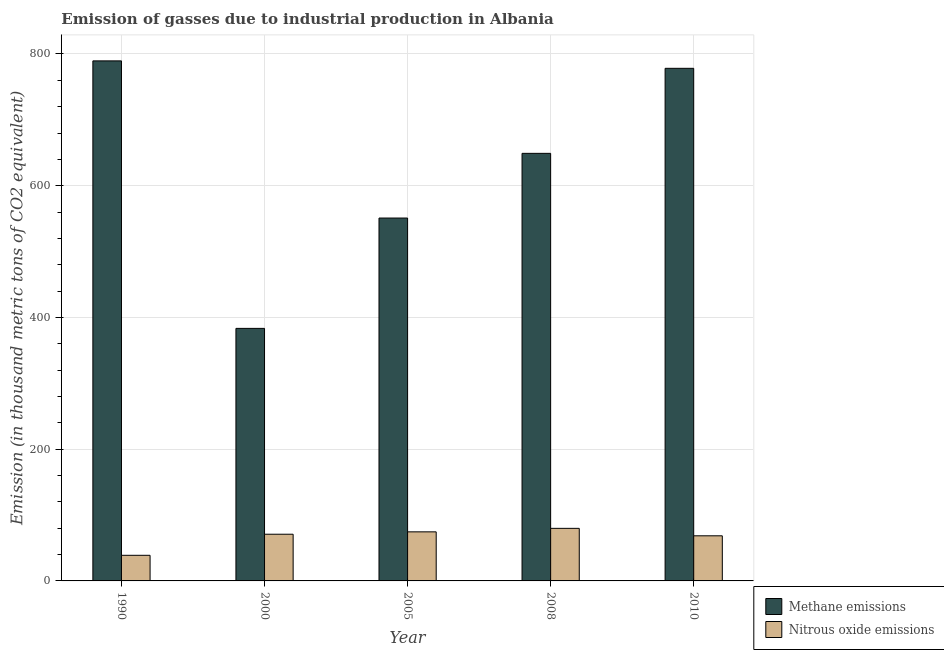Are the number of bars per tick equal to the number of legend labels?
Your response must be concise. Yes. In how many cases, is the number of bars for a given year not equal to the number of legend labels?
Offer a very short reply. 0. What is the amount of methane emissions in 2005?
Provide a succinct answer. 550.9. Across all years, what is the maximum amount of methane emissions?
Provide a short and direct response. 789.5. Across all years, what is the minimum amount of methane emissions?
Provide a succinct answer. 383.4. What is the total amount of methane emissions in the graph?
Provide a short and direct response. 3151.1. What is the difference between the amount of methane emissions in 1990 and that in 2010?
Make the answer very short. 11.3. What is the difference between the amount of methane emissions in 1990 and the amount of nitrous oxide emissions in 2000?
Give a very brief answer. 406.1. What is the average amount of nitrous oxide emissions per year?
Keep it short and to the point. 66.52. In the year 2010, what is the difference between the amount of nitrous oxide emissions and amount of methane emissions?
Offer a terse response. 0. What is the ratio of the amount of methane emissions in 1990 to that in 2008?
Give a very brief answer. 1.22. Is the difference between the amount of nitrous oxide emissions in 2000 and 2010 greater than the difference between the amount of methane emissions in 2000 and 2010?
Offer a very short reply. No. What is the difference between the highest and the second highest amount of methane emissions?
Keep it short and to the point. 11.3. What is the difference between the highest and the lowest amount of methane emissions?
Your answer should be compact. 406.1. In how many years, is the amount of nitrous oxide emissions greater than the average amount of nitrous oxide emissions taken over all years?
Offer a terse response. 4. Is the sum of the amount of nitrous oxide emissions in 1990 and 2005 greater than the maximum amount of methane emissions across all years?
Offer a very short reply. Yes. What does the 1st bar from the left in 2005 represents?
Your answer should be very brief. Methane emissions. What does the 2nd bar from the right in 2000 represents?
Offer a very short reply. Methane emissions. How many bars are there?
Give a very brief answer. 10. What is the difference between two consecutive major ticks on the Y-axis?
Your response must be concise. 200. Does the graph contain any zero values?
Your answer should be compact. No. Does the graph contain grids?
Your answer should be very brief. Yes. How many legend labels are there?
Make the answer very short. 2. What is the title of the graph?
Ensure brevity in your answer.  Emission of gasses due to industrial production in Albania. Does "Import" appear as one of the legend labels in the graph?
Make the answer very short. No. What is the label or title of the X-axis?
Provide a succinct answer. Year. What is the label or title of the Y-axis?
Your answer should be compact. Emission (in thousand metric tons of CO2 equivalent). What is the Emission (in thousand metric tons of CO2 equivalent) in Methane emissions in 1990?
Your response must be concise. 789.5. What is the Emission (in thousand metric tons of CO2 equivalent) in Nitrous oxide emissions in 1990?
Keep it short and to the point. 38.9. What is the Emission (in thousand metric tons of CO2 equivalent) of Methane emissions in 2000?
Provide a short and direct response. 383.4. What is the Emission (in thousand metric tons of CO2 equivalent) in Nitrous oxide emissions in 2000?
Your response must be concise. 70.9. What is the Emission (in thousand metric tons of CO2 equivalent) of Methane emissions in 2005?
Your answer should be compact. 550.9. What is the Emission (in thousand metric tons of CO2 equivalent) in Nitrous oxide emissions in 2005?
Your response must be concise. 74.5. What is the Emission (in thousand metric tons of CO2 equivalent) in Methane emissions in 2008?
Make the answer very short. 649.1. What is the Emission (in thousand metric tons of CO2 equivalent) in Nitrous oxide emissions in 2008?
Your answer should be compact. 79.8. What is the Emission (in thousand metric tons of CO2 equivalent) of Methane emissions in 2010?
Your response must be concise. 778.2. What is the Emission (in thousand metric tons of CO2 equivalent) of Nitrous oxide emissions in 2010?
Your answer should be compact. 68.5. Across all years, what is the maximum Emission (in thousand metric tons of CO2 equivalent) in Methane emissions?
Make the answer very short. 789.5. Across all years, what is the maximum Emission (in thousand metric tons of CO2 equivalent) of Nitrous oxide emissions?
Provide a short and direct response. 79.8. Across all years, what is the minimum Emission (in thousand metric tons of CO2 equivalent) in Methane emissions?
Offer a terse response. 383.4. Across all years, what is the minimum Emission (in thousand metric tons of CO2 equivalent) in Nitrous oxide emissions?
Your response must be concise. 38.9. What is the total Emission (in thousand metric tons of CO2 equivalent) of Methane emissions in the graph?
Give a very brief answer. 3151.1. What is the total Emission (in thousand metric tons of CO2 equivalent) in Nitrous oxide emissions in the graph?
Make the answer very short. 332.6. What is the difference between the Emission (in thousand metric tons of CO2 equivalent) of Methane emissions in 1990 and that in 2000?
Your response must be concise. 406.1. What is the difference between the Emission (in thousand metric tons of CO2 equivalent) in Nitrous oxide emissions in 1990 and that in 2000?
Ensure brevity in your answer.  -32. What is the difference between the Emission (in thousand metric tons of CO2 equivalent) in Methane emissions in 1990 and that in 2005?
Give a very brief answer. 238.6. What is the difference between the Emission (in thousand metric tons of CO2 equivalent) of Nitrous oxide emissions in 1990 and that in 2005?
Provide a short and direct response. -35.6. What is the difference between the Emission (in thousand metric tons of CO2 equivalent) of Methane emissions in 1990 and that in 2008?
Provide a short and direct response. 140.4. What is the difference between the Emission (in thousand metric tons of CO2 equivalent) in Nitrous oxide emissions in 1990 and that in 2008?
Offer a terse response. -40.9. What is the difference between the Emission (in thousand metric tons of CO2 equivalent) of Nitrous oxide emissions in 1990 and that in 2010?
Keep it short and to the point. -29.6. What is the difference between the Emission (in thousand metric tons of CO2 equivalent) of Methane emissions in 2000 and that in 2005?
Offer a terse response. -167.5. What is the difference between the Emission (in thousand metric tons of CO2 equivalent) of Methane emissions in 2000 and that in 2008?
Your answer should be very brief. -265.7. What is the difference between the Emission (in thousand metric tons of CO2 equivalent) in Methane emissions in 2000 and that in 2010?
Keep it short and to the point. -394.8. What is the difference between the Emission (in thousand metric tons of CO2 equivalent) in Methane emissions in 2005 and that in 2008?
Your answer should be compact. -98.2. What is the difference between the Emission (in thousand metric tons of CO2 equivalent) of Methane emissions in 2005 and that in 2010?
Keep it short and to the point. -227.3. What is the difference between the Emission (in thousand metric tons of CO2 equivalent) of Nitrous oxide emissions in 2005 and that in 2010?
Provide a short and direct response. 6. What is the difference between the Emission (in thousand metric tons of CO2 equivalent) in Methane emissions in 2008 and that in 2010?
Make the answer very short. -129.1. What is the difference between the Emission (in thousand metric tons of CO2 equivalent) in Methane emissions in 1990 and the Emission (in thousand metric tons of CO2 equivalent) in Nitrous oxide emissions in 2000?
Keep it short and to the point. 718.6. What is the difference between the Emission (in thousand metric tons of CO2 equivalent) in Methane emissions in 1990 and the Emission (in thousand metric tons of CO2 equivalent) in Nitrous oxide emissions in 2005?
Provide a succinct answer. 715. What is the difference between the Emission (in thousand metric tons of CO2 equivalent) of Methane emissions in 1990 and the Emission (in thousand metric tons of CO2 equivalent) of Nitrous oxide emissions in 2008?
Your answer should be very brief. 709.7. What is the difference between the Emission (in thousand metric tons of CO2 equivalent) in Methane emissions in 1990 and the Emission (in thousand metric tons of CO2 equivalent) in Nitrous oxide emissions in 2010?
Your response must be concise. 721. What is the difference between the Emission (in thousand metric tons of CO2 equivalent) in Methane emissions in 2000 and the Emission (in thousand metric tons of CO2 equivalent) in Nitrous oxide emissions in 2005?
Your response must be concise. 308.9. What is the difference between the Emission (in thousand metric tons of CO2 equivalent) in Methane emissions in 2000 and the Emission (in thousand metric tons of CO2 equivalent) in Nitrous oxide emissions in 2008?
Make the answer very short. 303.6. What is the difference between the Emission (in thousand metric tons of CO2 equivalent) in Methane emissions in 2000 and the Emission (in thousand metric tons of CO2 equivalent) in Nitrous oxide emissions in 2010?
Your answer should be very brief. 314.9. What is the difference between the Emission (in thousand metric tons of CO2 equivalent) of Methane emissions in 2005 and the Emission (in thousand metric tons of CO2 equivalent) of Nitrous oxide emissions in 2008?
Make the answer very short. 471.1. What is the difference between the Emission (in thousand metric tons of CO2 equivalent) of Methane emissions in 2005 and the Emission (in thousand metric tons of CO2 equivalent) of Nitrous oxide emissions in 2010?
Offer a very short reply. 482.4. What is the difference between the Emission (in thousand metric tons of CO2 equivalent) in Methane emissions in 2008 and the Emission (in thousand metric tons of CO2 equivalent) in Nitrous oxide emissions in 2010?
Your answer should be very brief. 580.6. What is the average Emission (in thousand metric tons of CO2 equivalent) in Methane emissions per year?
Offer a terse response. 630.22. What is the average Emission (in thousand metric tons of CO2 equivalent) in Nitrous oxide emissions per year?
Provide a succinct answer. 66.52. In the year 1990, what is the difference between the Emission (in thousand metric tons of CO2 equivalent) in Methane emissions and Emission (in thousand metric tons of CO2 equivalent) in Nitrous oxide emissions?
Give a very brief answer. 750.6. In the year 2000, what is the difference between the Emission (in thousand metric tons of CO2 equivalent) of Methane emissions and Emission (in thousand metric tons of CO2 equivalent) of Nitrous oxide emissions?
Keep it short and to the point. 312.5. In the year 2005, what is the difference between the Emission (in thousand metric tons of CO2 equivalent) in Methane emissions and Emission (in thousand metric tons of CO2 equivalent) in Nitrous oxide emissions?
Provide a succinct answer. 476.4. In the year 2008, what is the difference between the Emission (in thousand metric tons of CO2 equivalent) in Methane emissions and Emission (in thousand metric tons of CO2 equivalent) in Nitrous oxide emissions?
Provide a succinct answer. 569.3. In the year 2010, what is the difference between the Emission (in thousand metric tons of CO2 equivalent) of Methane emissions and Emission (in thousand metric tons of CO2 equivalent) of Nitrous oxide emissions?
Offer a terse response. 709.7. What is the ratio of the Emission (in thousand metric tons of CO2 equivalent) of Methane emissions in 1990 to that in 2000?
Your response must be concise. 2.06. What is the ratio of the Emission (in thousand metric tons of CO2 equivalent) in Nitrous oxide emissions in 1990 to that in 2000?
Provide a succinct answer. 0.55. What is the ratio of the Emission (in thousand metric tons of CO2 equivalent) of Methane emissions in 1990 to that in 2005?
Your response must be concise. 1.43. What is the ratio of the Emission (in thousand metric tons of CO2 equivalent) in Nitrous oxide emissions in 1990 to that in 2005?
Provide a succinct answer. 0.52. What is the ratio of the Emission (in thousand metric tons of CO2 equivalent) of Methane emissions in 1990 to that in 2008?
Give a very brief answer. 1.22. What is the ratio of the Emission (in thousand metric tons of CO2 equivalent) in Nitrous oxide emissions in 1990 to that in 2008?
Make the answer very short. 0.49. What is the ratio of the Emission (in thousand metric tons of CO2 equivalent) of Methane emissions in 1990 to that in 2010?
Your answer should be compact. 1.01. What is the ratio of the Emission (in thousand metric tons of CO2 equivalent) of Nitrous oxide emissions in 1990 to that in 2010?
Offer a very short reply. 0.57. What is the ratio of the Emission (in thousand metric tons of CO2 equivalent) in Methane emissions in 2000 to that in 2005?
Give a very brief answer. 0.7. What is the ratio of the Emission (in thousand metric tons of CO2 equivalent) in Nitrous oxide emissions in 2000 to that in 2005?
Offer a very short reply. 0.95. What is the ratio of the Emission (in thousand metric tons of CO2 equivalent) in Methane emissions in 2000 to that in 2008?
Keep it short and to the point. 0.59. What is the ratio of the Emission (in thousand metric tons of CO2 equivalent) of Nitrous oxide emissions in 2000 to that in 2008?
Your answer should be compact. 0.89. What is the ratio of the Emission (in thousand metric tons of CO2 equivalent) in Methane emissions in 2000 to that in 2010?
Your answer should be very brief. 0.49. What is the ratio of the Emission (in thousand metric tons of CO2 equivalent) in Nitrous oxide emissions in 2000 to that in 2010?
Offer a terse response. 1.03. What is the ratio of the Emission (in thousand metric tons of CO2 equivalent) in Methane emissions in 2005 to that in 2008?
Provide a short and direct response. 0.85. What is the ratio of the Emission (in thousand metric tons of CO2 equivalent) of Nitrous oxide emissions in 2005 to that in 2008?
Keep it short and to the point. 0.93. What is the ratio of the Emission (in thousand metric tons of CO2 equivalent) in Methane emissions in 2005 to that in 2010?
Offer a terse response. 0.71. What is the ratio of the Emission (in thousand metric tons of CO2 equivalent) of Nitrous oxide emissions in 2005 to that in 2010?
Make the answer very short. 1.09. What is the ratio of the Emission (in thousand metric tons of CO2 equivalent) in Methane emissions in 2008 to that in 2010?
Offer a very short reply. 0.83. What is the ratio of the Emission (in thousand metric tons of CO2 equivalent) of Nitrous oxide emissions in 2008 to that in 2010?
Ensure brevity in your answer.  1.17. What is the difference between the highest and the second highest Emission (in thousand metric tons of CO2 equivalent) in Methane emissions?
Your response must be concise. 11.3. What is the difference between the highest and the second highest Emission (in thousand metric tons of CO2 equivalent) of Nitrous oxide emissions?
Provide a succinct answer. 5.3. What is the difference between the highest and the lowest Emission (in thousand metric tons of CO2 equivalent) in Methane emissions?
Ensure brevity in your answer.  406.1. What is the difference between the highest and the lowest Emission (in thousand metric tons of CO2 equivalent) of Nitrous oxide emissions?
Your answer should be compact. 40.9. 